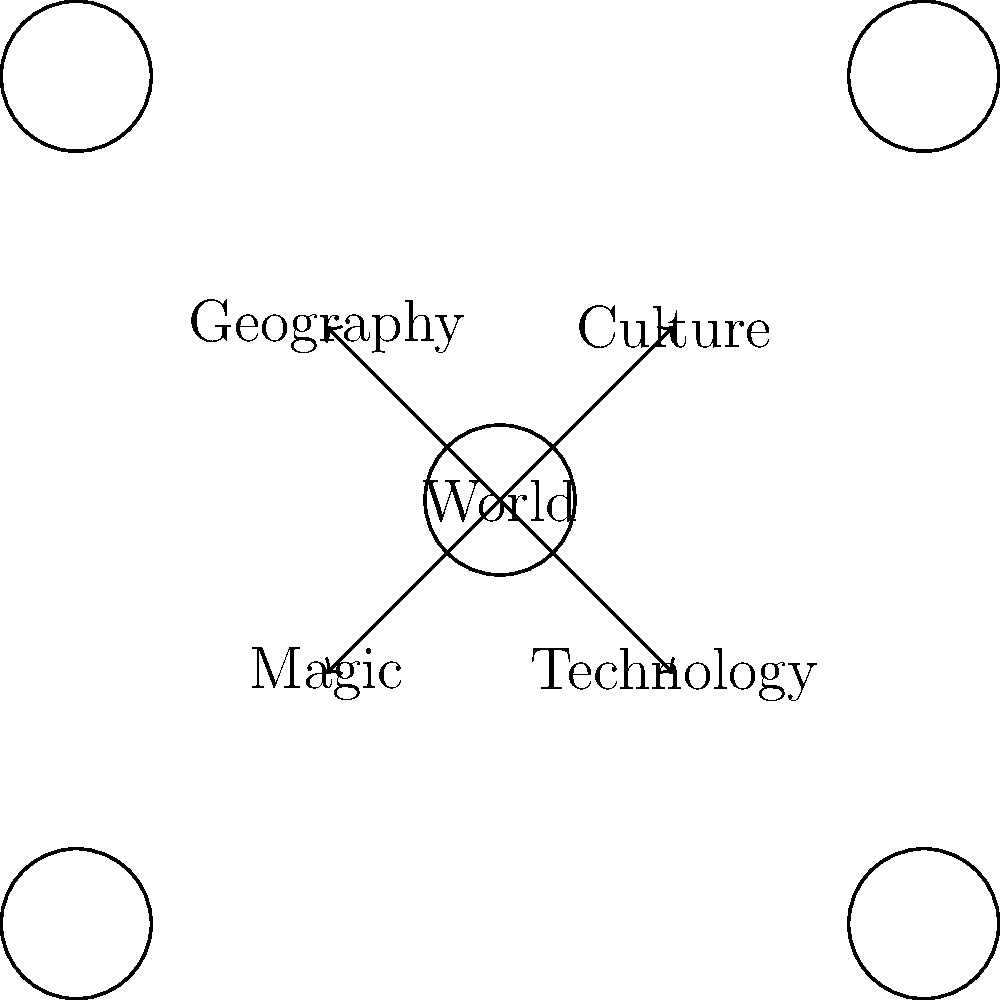In the context of world-building for speculative fiction, which element in the mind map above would be most appropriate to expand upon when developing a story set in a post-apocalyptic society where ancient magical artifacts have resurfaced? To answer this question, we need to analyze each element in the mind map and consider how it relates to the given story premise:

1. Geography: While important for any world-building, it's not the most crucial element for this specific scenario.

2. Culture: This is significant, as the post-apocalyptic setting would greatly influence societal norms and behaviors. However, it's not the primary focus given the magical aspect of the premise.

3. Magic: This element is directly related to the "ancient magical artifacts" mentioned in the story premise. It would be crucial to expand upon the magic system, its history, and how it interacts with the post-apocalyptic world.

4. Technology: In a post-apocalyptic setting, technology would play a role, but it's not as central as the magical elements in this case.

Given the story premise of a post-apocalyptic society where ancient magical artifacts have resurfaced, the most appropriate element to expand upon would be "Magic." This choice allows the writer to delve into the magical system, its origins, how it relates to the artifacts, and its impact on the post-apocalyptic world.
Answer: Magic 